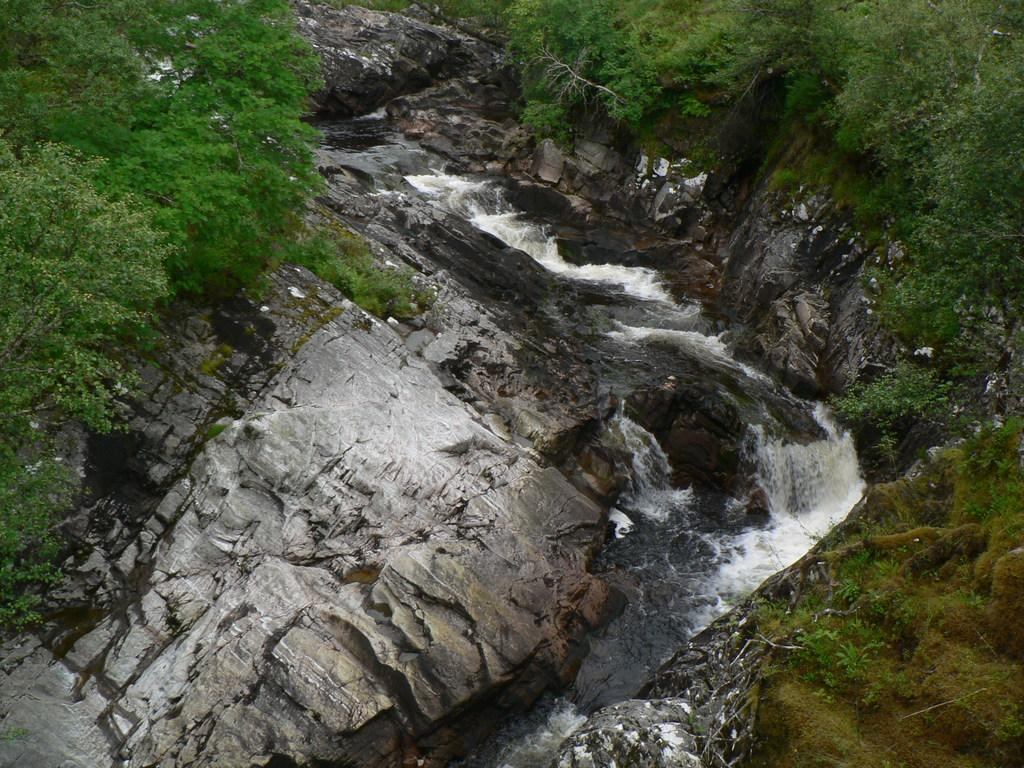What type of landform is present in the image? There is a hill in the image. What type of vegetation can be seen on the hill? Grass is visible on the hill. What type of water feature is present in the image? There is a water fountain visible on a lake. How many ducks are swimming in the lake near the water fountain? There is no duck present in the image; only a water fountain on a lake is visible. What type of soda is being served at the top of the hill? There is no soda present in the image; only a hill with grass is visible. 